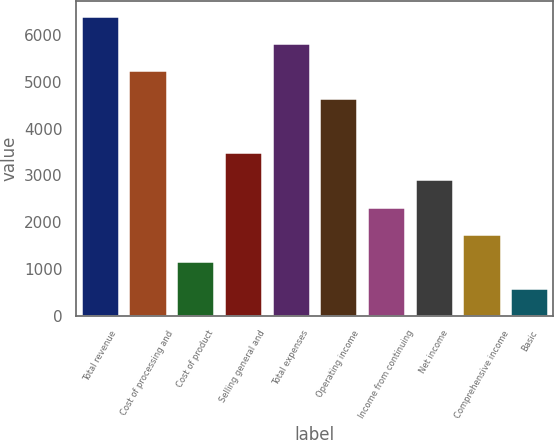Convert chart to OTSL. <chart><loc_0><loc_0><loc_500><loc_500><bar_chart><fcel>Total revenue<fcel>Cost of processing and<fcel>Cost of product<fcel>Selling general and<fcel>Total expenses<fcel>Operating income<fcel>Income from continuing<fcel>Net income<fcel>Comprehensive income<fcel>Basic<nl><fcel>6404.98<fcel>5240.96<fcel>1166.89<fcel>3494.93<fcel>5822.97<fcel>4658.95<fcel>2330.91<fcel>2912.92<fcel>1748.9<fcel>584.88<nl></chart> 